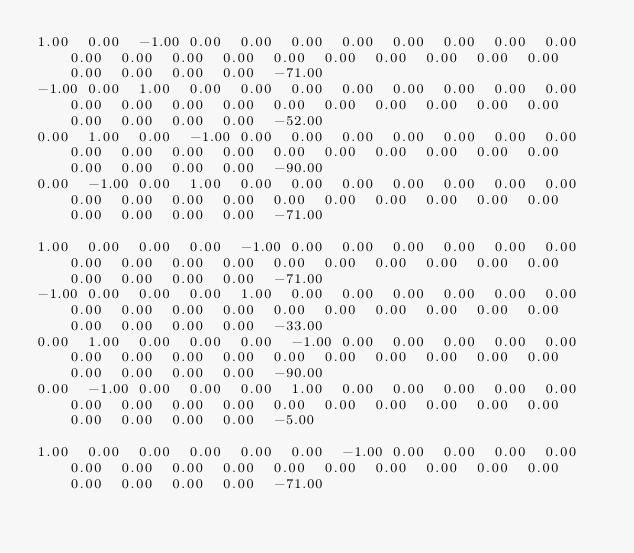<code> <loc_0><loc_0><loc_500><loc_500><_Matlab_>1.00	0.00	-1.00	0.00	0.00	0.00	0.00	0.00	0.00	0.00	0.00	0.00	0.00	0.00	0.00	0.00	0.00	0.00	0.00	0.00	0.00	0.00	0.00	0.00	0.00	-71.00
-1.00	0.00	1.00	0.00	0.00	0.00	0.00	0.00	0.00	0.00	0.00	0.00	0.00	0.00	0.00	0.00	0.00	0.00	0.00	0.00	0.00	0.00	0.00	0.00	0.00	-52.00
0.00	1.00	0.00	-1.00	0.00	0.00	0.00	0.00	0.00	0.00	0.00	0.00	0.00	0.00	0.00	0.00	0.00	0.00	0.00	0.00	0.00	0.00	0.00	0.00	0.00	-90.00
0.00	-1.00	0.00	1.00	0.00	0.00	0.00	0.00	0.00	0.00	0.00	0.00	0.00	0.00	0.00	0.00	0.00	0.00	0.00	0.00	0.00	0.00	0.00	0.00	0.00	-71.00

1.00	0.00	0.00	0.00	-1.00	0.00	0.00	0.00	0.00	0.00	0.00	0.00	0.00	0.00	0.00	0.00	0.00	0.00	0.00	0.00	0.00	0.00	0.00	0.00	0.00	-71.00
-1.00	0.00	0.00	0.00	1.00	0.00	0.00	0.00	0.00	0.00	0.00	0.00	0.00	0.00	0.00	0.00	0.00	0.00	0.00	0.00	0.00	0.00	0.00	0.00	0.00	-33.00
0.00	1.00	0.00	0.00	0.00	-1.00	0.00	0.00	0.00	0.00	0.00	0.00	0.00	0.00	0.00	0.00	0.00	0.00	0.00	0.00	0.00	0.00	0.00	0.00	0.00	-90.00
0.00	-1.00	0.00	0.00	0.00	1.00	0.00	0.00	0.00	0.00	0.00	0.00	0.00	0.00	0.00	0.00	0.00	0.00	0.00	0.00	0.00	0.00	0.00	0.00	0.00	-5.00

1.00	0.00	0.00	0.00	0.00	0.00	-1.00	0.00	0.00	0.00	0.00	0.00	0.00	0.00	0.00	0.00	0.00	0.00	0.00	0.00	0.00	0.00	0.00	0.00	0.00	-71.00</code> 